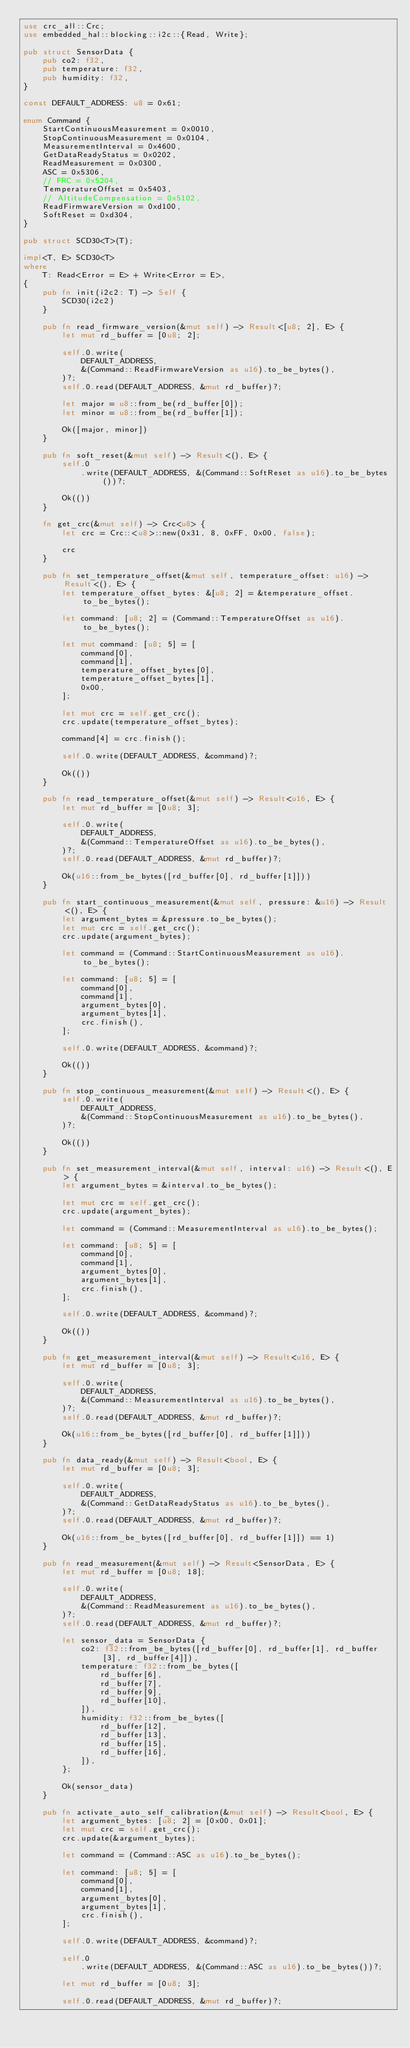Convert code to text. <code><loc_0><loc_0><loc_500><loc_500><_Rust_>use crc_all::Crc;
use embedded_hal::blocking::i2c::{Read, Write};

pub struct SensorData {
    pub co2: f32,
    pub temperature: f32,
    pub humidity: f32,
}

const DEFAULT_ADDRESS: u8 = 0x61;

enum Command {
    StartContinuousMeasurement = 0x0010,
    StopContinuousMeasurement = 0x0104,
    MeasurementInterval = 0x4600,
    GetDataReadyStatus = 0x0202,
    ReadMeasurement = 0x0300,
    ASC = 0x5306,
    // FRC = 0x5204,
    TemperatureOffset = 0x5403,
    // AltitudeCompensation = 0x5102,
    ReadFirmwareVersion = 0xd100,
    SoftReset = 0xd304,
}

pub struct SCD30<T>(T);

impl<T, E> SCD30<T>
where
    T: Read<Error = E> + Write<Error = E>,
{
    pub fn init(i2c2: T) -> Self {
        SCD30(i2c2)
    }

    pub fn read_firmware_version(&mut self) -> Result<[u8; 2], E> {
        let mut rd_buffer = [0u8; 2];

        self.0.write(
            DEFAULT_ADDRESS,
            &(Command::ReadFirmwareVersion as u16).to_be_bytes(),
        )?;
        self.0.read(DEFAULT_ADDRESS, &mut rd_buffer)?;

        let major = u8::from_be(rd_buffer[0]);
        let minor = u8::from_be(rd_buffer[1]);

        Ok([major, minor])
    }

    pub fn soft_reset(&mut self) -> Result<(), E> {
        self.0
            .write(DEFAULT_ADDRESS, &(Command::SoftReset as u16).to_be_bytes())?;

        Ok(())
    }

    fn get_crc(&mut self) -> Crc<u8> {
        let crc = Crc::<u8>::new(0x31, 8, 0xFF, 0x00, false);

        crc
    }

    pub fn set_temperature_offset(&mut self, temperature_offset: u16) -> Result<(), E> {
        let temperature_offset_bytes: &[u8; 2] = &temperature_offset.to_be_bytes();

        let command: [u8; 2] = (Command::TemperatureOffset as u16).to_be_bytes();

        let mut command: [u8; 5] = [
            command[0],
            command[1],
            temperature_offset_bytes[0],
            temperature_offset_bytes[1],
            0x00,
        ];

        let mut crc = self.get_crc();
        crc.update(temperature_offset_bytes);

        command[4] = crc.finish();

        self.0.write(DEFAULT_ADDRESS, &command)?;

        Ok(())
    }

    pub fn read_temperature_offset(&mut self) -> Result<u16, E> {
        let mut rd_buffer = [0u8; 3];

        self.0.write(
            DEFAULT_ADDRESS,
            &(Command::TemperatureOffset as u16).to_be_bytes(),
        )?;
        self.0.read(DEFAULT_ADDRESS, &mut rd_buffer)?;

        Ok(u16::from_be_bytes([rd_buffer[0], rd_buffer[1]]))
    }

    pub fn start_continuous_measurement(&mut self, pressure: &u16) -> Result<(), E> {
        let argument_bytes = &pressure.to_be_bytes();
        let mut crc = self.get_crc();
        crc.update(argument_bytes);

        let command = (Command::StartContinuousMeasurement as u16).to_be_bytes();

        let command: [u8; 5] = [
            command[0],
            command[1],
            argument_bytes[0],
            argument_bytes[1],
            crc.finish(),
        ];

        self.0.write(DEFAULT_ADDRESS, &command)?;

        Ok(())
    }

    pub fn stop_continuous_measurement(&mut self) -> Result<(), E> {
        self.0.write(
            DEFAULT_ADDRESS,
            &(Command::StopContinuousMeasurement as u16).to_be_bytes(),
        )?;

        Ok(())
    }

    pub fn set_measurement_interval(&mut self, interval: u16) -> Result<(), E> {
        let argument_bytes = &interval.to_be_bytes();

        let mut crc = self.get_crc();
        crc.update(argument_bytes);

        let command = (Command::MeasurementInterval as u16).to_be_bytes();

        let command: [u8; 5] = [
            command[0],
            command[1],
            argument_bytes[0],
            argument_bytes[1],
            crc.finish(),
        ];

        self.0.write(DEFAULT_ADDRESS, &command)?;

        Ok(())
    }

    pub fn get_measurement_interval(&mut self) -> Result<u16, E> {
        let mut rd_buffer = [0u8; 3];

        self.0.write(
            DEFAULT_ADDRESS,
            &(Command::MeasurementInterval as u16).to_be_bytes(),
        )?;
        self.0.read(DEFAULT_ADDRESS, &mut rd_buffer)?;

        Ok(u16::from_be_bytes([rd_buffer[0], rd_buffer[1]]))
    }

    pub fn data_ready(&mut self) -> Result<bool, E> {
        let mut rd_buffer = [0u8; 3];

        self.0.write(
            DEFAULT_ADDRESS,
            &(Command::GetDataReadyStatus as u16).to_be_bytes(),
        )?;
        self.0.read(DEFAULT_ADDRESS, &mut rd_buffer)?;

        Ok(u16::from_be_bytes([rd_buffer[0], rd_buffer[1]]) == 1)
    }

    pub fn read_measurement(&mut self) -> Result<SensorData, E> {
        let mut rd_buffer = [0u8; 18];

        self.0.write(
            DEFAULT_ADDRESS,
            &(Command::ReadMeasurement as u16).to_be_bytes(),
        )?;
        self.0.read(DEFAULT_ADDRESS, &mut rd_buffer)?;

        let sensor_data = SensorData {
            co2: f32::from_be_bytes([rd_buffer[0], rd_buffer[1], rd_buffer[3], rd_buffer[4]]),
            temperature: f32::from_be_bytes([
                rd_buffer[6],
                rd_buffer[7],
                rd_buffer[9],
                rd_buffer[10],
            ]),
            humidity: f32::from_be_bytes([
                rd_buffer[12],
                rd_buffer[13],
                rd_buffer[15],
                rd_buffer[16],
            ]),
        };

        Ok(sensor_data)
    }

    pub fn activate_auto_self_calibration(&mut self) -> Result<bool, E> {
        let argument_bytes: [u8; 2] = [0x00, 0x01];
        let mut crc = self.get_crc();
        crc.update(&argument_bytes);

        let command = (Command::ASC as u16).to_be_bytes();

        let command: [u8; 5] = [
            command[0],
            command[1],
            argument_bytes[0],
            argument_bytes[1],
            crc.finish(),
        ];

        self.0.write(DEFAULT_ADDRESS, &command)?;

        self.0
            .write(DEFAULT_ADDRESS, &(Command::ASC as u16).to_be_bytes())?;

        let mut rd_buffer = [0u8; 3];

        self.0.read(DEFAULT_ADDRESS, &mut rd_buffer)?;
</code> 